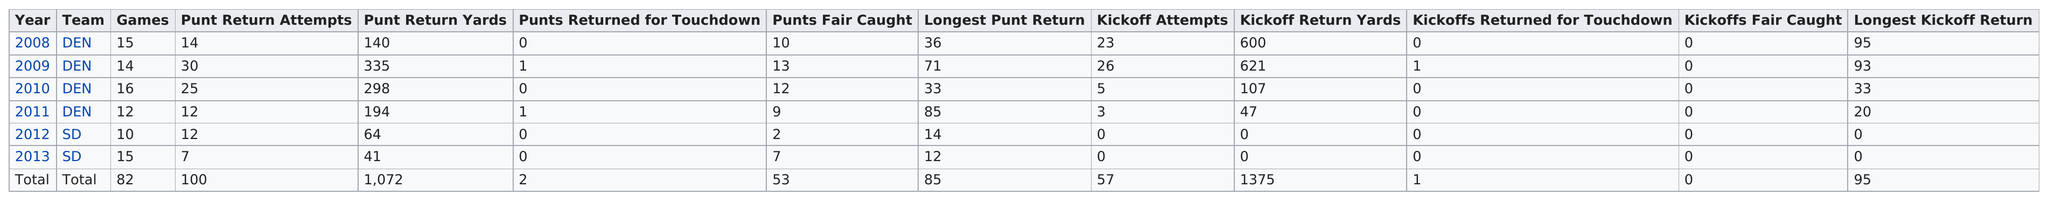Specify some key components in this picture. In the following year, after having 20 punt return attempts in the previous year, the number of punt return attempts decreased to 7. This occurred in the year 2012. In 2013, the year with the least amount of punt return attempts was recorded. In 2008, Eddie Royal was the first to join the league. Of the two punts that were returned for a touchdown, how many were there? In 2012, there were 5 fewer punt return attempts than in 2013. 